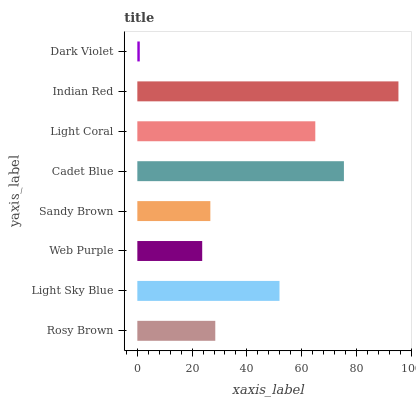Is Dark Violet the minimum?
Answer yes or no. Yes. Is Indian Red the maximum?
Answer yes or no. Yes. Is Light Sky Blue the minimum?
Answer yes or no. No. Is Light Sky Blue the maximum?
Answer yes or no. No. Is Light Sky Blue greater than Rosy Brown?
Answer yes or no. Yes. Is Rosy Brown less than Light Sky Blue?
Answer yes or no. Yes. Is Rosy Brown greater than Light Sky Blue?
Answer yes or no. No. Is Light Sky Blue less than Rosy Brown?
Answer yes or no. No. Is Light Sky Blue the high median?
Answer yes or no. Yes. Is Rosy Brown the low median?
Answer yes or no. Yes. Is Cadet Blue the high median?
Answer yes or no. No. Is Light Sky Blue the low median?
Answer yes or no. No. 